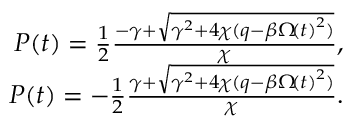Convert formula to latex. <formula><loc_0><loc_0><loc_500><loc_500>\begin{array} { r } { P \, \left ( t \right ) = \frac { 1 } { 2 } \frac { - \gamma + \sqrt { \gamma ^ { 2 } + 4 \chi ( q - \beta \Omega \, \left ( t \right ) ^ { 2 } ) } } { \chi } , } \\ { P \, \left ( t \right ) = - \frac { 1 } { 2 } \frac { \gamma + \sqrt { \gamma ^ { 2 } + 4 \chi ( q - \beta \Omega \, \left ( t \right ) ^ { 2 } ) } } { \chi } . } \end{array}</formula> 